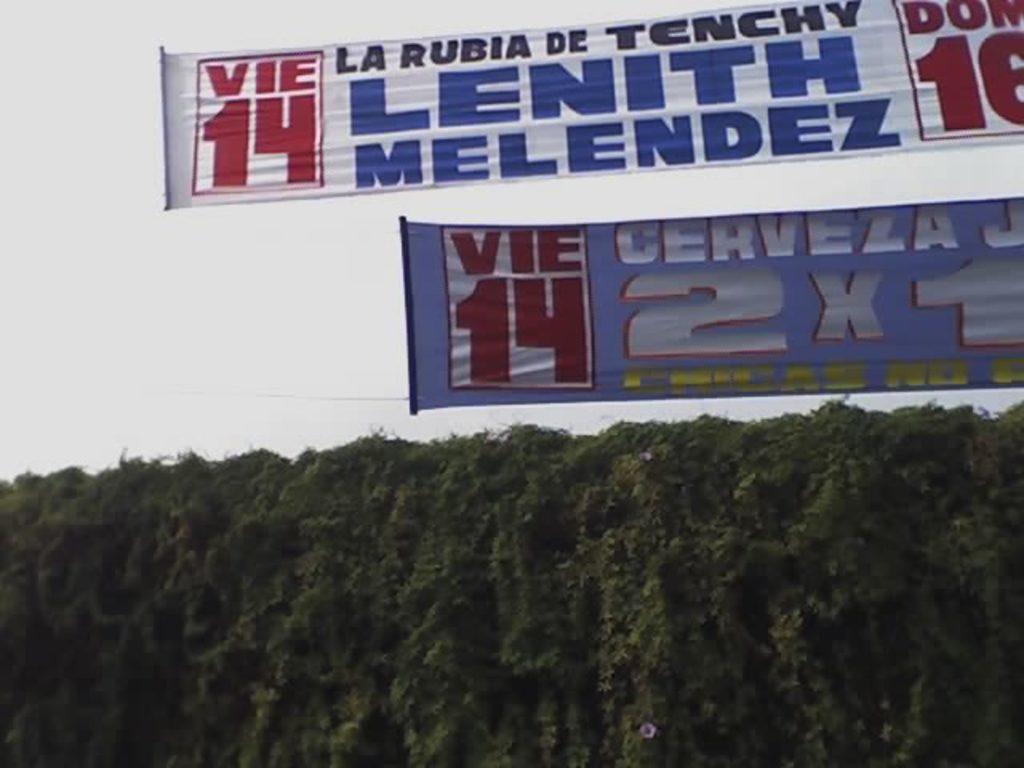Could you give a brief overview of what you see in this image? At the bottom of the image there are some trees. At the top of the image there are some banners. Behind the banners there is sky. 